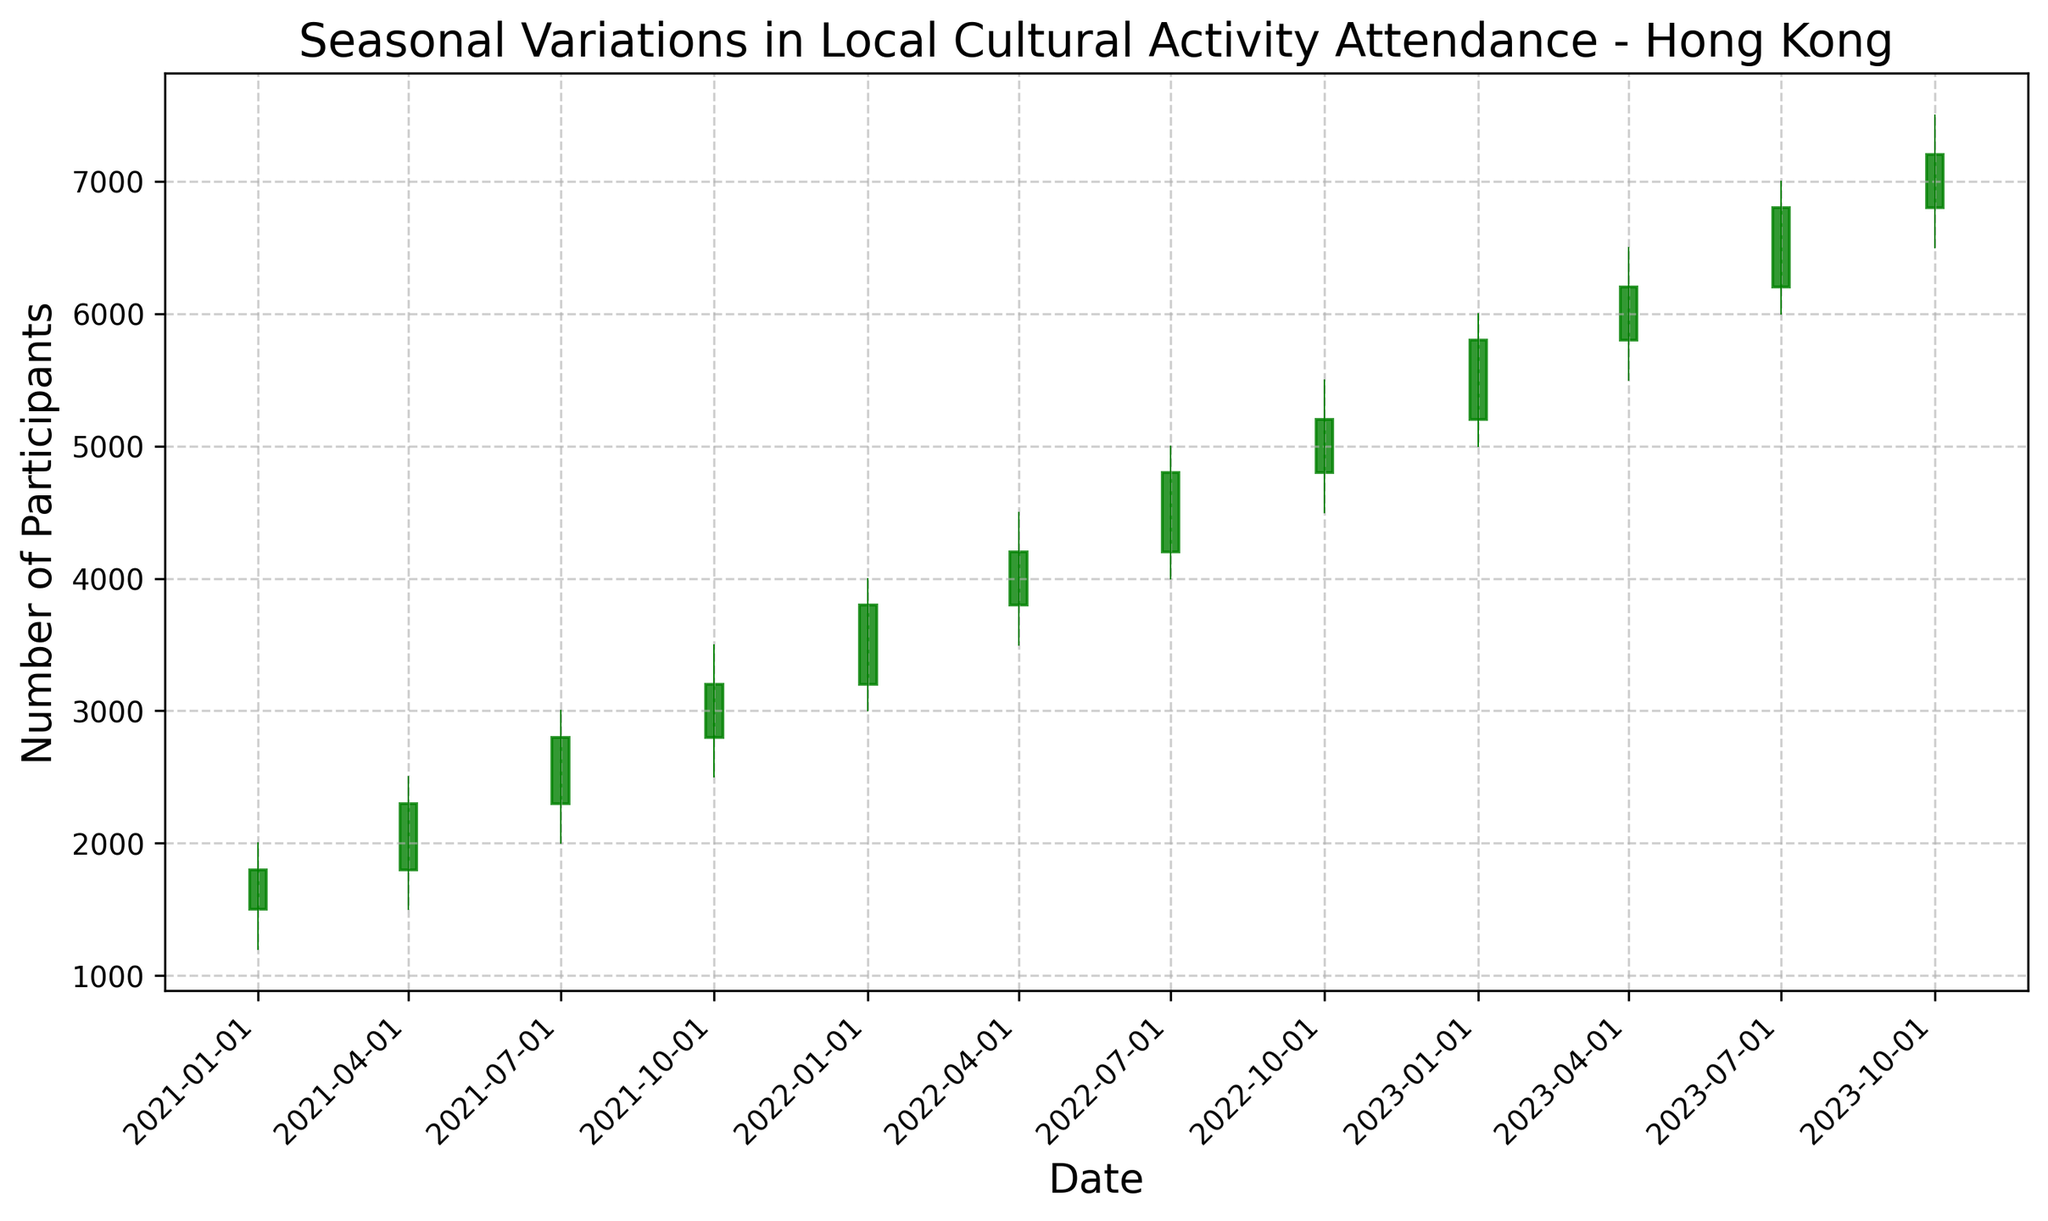How does the participation in local cultural activities change from January 2021 to October 2023? The plot shows a clear upward trend in the participants' numbers over the given period. Starting from January 2021 with a closing number of 1800, to October 2023 with a closing number of 7200, there's a consistent increase, demonstrating growing interest in local cultural activities.
Answer: Upward trend Which season shows the highest number of participants in local cultural activities consistently? By observing the candlestick chart, each year's participant peaks in the October season. The closing values for October from 2021 to 2023 are 3200, 5200, and 7200, respectively, which are the highest among their respective years.
Answer: October Is there any season where the number of participants decreases from one year to the next? Reviewing the closing values per season, every year sees an increase in participants compared to the previous year for all seasons. Thus, there are no seasons where the number of participants decreases from one year to the next.
Answer: No What is the average number of participants per season over the entire period? First, sum up the closing numbers for each season: (1800 + 2300 + 2800 + 3200 + 3800 + 4200 + 4800 + 5200 + 5800 + 6200 + 6800 + 7200), which equals 54300. There are 12 seasons, so the average is 54300 / 12 = 4525.
Answer: 4525 During which quarter did the highest increase in participants occur, and what was the amount of increase? The highest increase appears between October 2022 and January 2023. The closing values increase from 5200 to 5800, which is an increase of 600 participants.
Answer: October 2022 to January 2023, increase of 600 participants Compare the number of participants in April 2021 and April 2023. How much did it increase, percentage-wise? The number of participants in April 2021 is 2300, and in April 2023, it is 6200. The increase is 6200 - 2300 = 3900. The percentage increase is (3900 / 2300) * 100 ≈ 169.57%.
Answer: 169.57% Which quarter in 2022 recorded the lowest number of participants, and what was that number? By reviewing the closing values for each quarter in 2022, January had the lowest number of participants with a closing value of 3800.
Answer: January 2022, 3800 participants How do the volume trends relate to the number of participants shown by the candlestick chart? The trading volume (number of participants) consistently increases alongside the upward trend depicted by the candlestick chart, indicating higher participation year over year.
Answer: Positive correlation What color represents an increase in the number of participants in a particular season, and what color denotes a decrease? A green candlestick represents an increase in the number of participants from the season's open to close, while a red candlestick indicates a decrease in the number of participants.
Answer: Green for increase, Red for decrease 